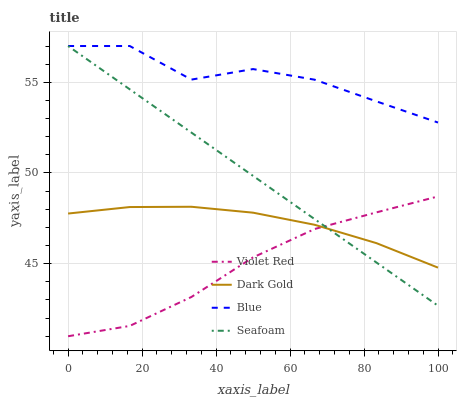Does Violet Red have the minimum area under the curve?
Answer yes or no. Yes. Does Blue have the maximum area under the curve?
Answer yes or no. Yes. Does Seafoam have the minimum area under the curve?
Answer yes or no. No. Does Seafoam have the maximum area under the curve?
Answer yes or no. No. Is Seafoam the smoothest?
Answer yes or no. Yes. Is Blue the roughest?
Answer yes or no. Yes. Is Violet Red the smoothest?
Answer yes or no. No. Is Violet Red the roughest?
Answer yes or no. No. Does Violet Red have the lowest value?
Answer yes or no. Yes. Does Seafoam have the lowest value?
Answer yes or no. No. Does Seafoam have the highest value?
Answer yes or no. Yes. Does Violet Red have the highest value?
Answer yes or no. No. Is Dark Gold less than Blue?
Answer yes or no. Yes. Is Blue greater than Violet Red?
Answer yes or no. Yes. Does Violet Red intersect Dark Gold?
Answer yes or no. Yes. Is Violet Red less than Dark Gold?
Answer yes or no. No. Is Violet Red greater than Dark Gold?
Answer yes or no. No. Does Dark Gold intersect Blue?
Answer yes or no. No. 